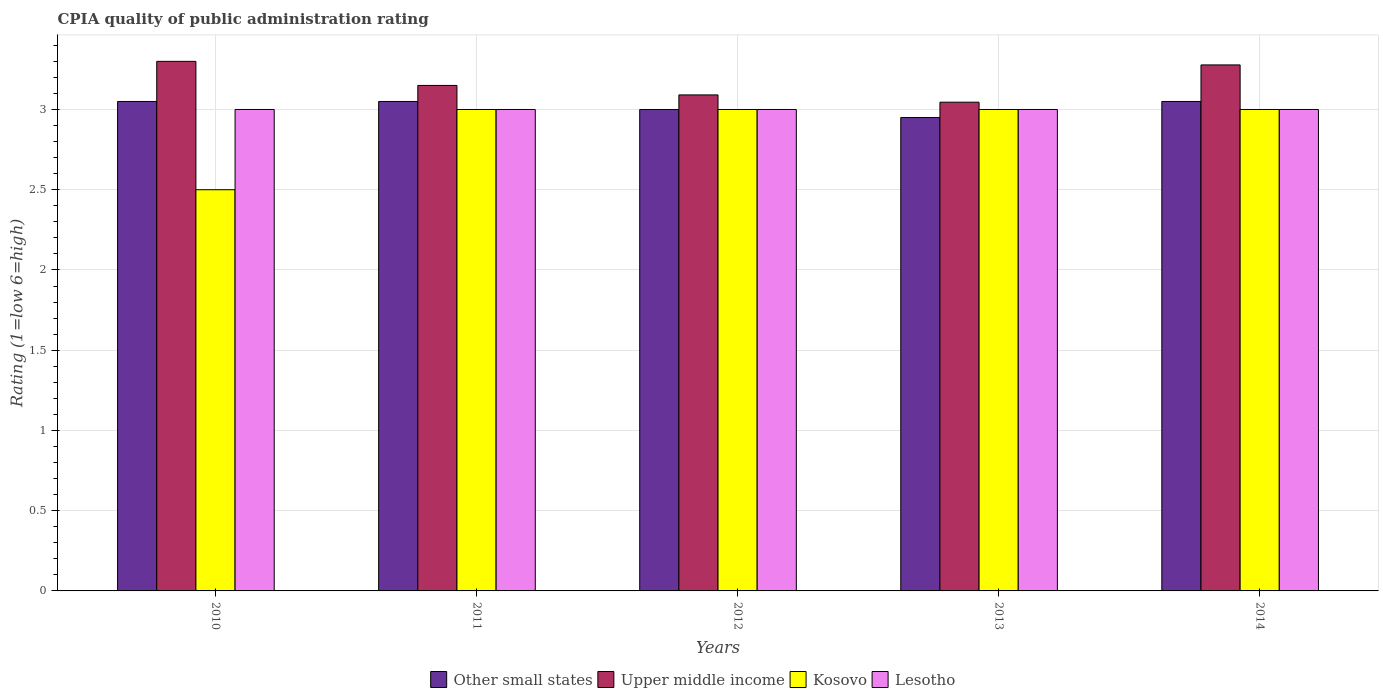How many different coloured bars are there?
Provide a short and direct response. 4. Are the number of bars per tick equal to the number of legend labels?
Your answer should be compact. Yes. Are the number of bars on each tick of the X-axis equal?
Your response must be concise. Yes. Across all years, what is the minimum CPIA rating in Upper middle income?
Ensure brevity in your answer.  3.05. In which year was the CPIA rating in Lesotho maximum?
Provide a succinct answer. 2010. In which year was the CPIA rating in Kosovo minimum?
Your response must be concise. 2010. What is the total CPIA rating in Other small states in the graph?
Your answer should be very brief. 15.1. What is the difference between the CPIA rating in Upper middle income in 2010 and the CPIA rating in Lesotho in 2014?
Your response must be concise. 0.3. What is the average CPIA rating in Lesotho per year?
Your answer should be compact. 3. In the year 2010, what is the difference between the CPIA rating in Upper middle income and CPIA rating in Kosovo?
Your answer should be compact. 0.8. What is the ratio of the CPIA rating in Other small states in 2012 to that in 2013?
Make the answer very short. 1.02. What is the difference between the highest and the second highest CPIA rating in Upper middle income?
Your response must be concise. 0.02. What is the difference between the highest and the lowest CPIA rating in Lesotho?
Your response must be concise. 0. Is it the case that in every year, the sum of the CPIA rating in Other small states and CPIA rating in Lesotho is greater than the sum of CPIA rating in Upper middle income and CPIA rating in Kosovo?
Offer a very short reply. No. What does the 3rd bar from the left in 2014 represents?
Provide a short and direct response. Kosovo. What does the 3rd bar from the right in 2012 represents?
Offer a terse response. Upper middle income. Is it the case that in every year, the sum of the CPIA rating in Kosovo and CPIA rating in Other small states is greater than the CPIA rating in Lesotho?
Offer a very short reply. Yes. What is the difference between two consecutive major ticks on the Y-axis?
Offer a very short reply. 0.5. Does the graph contain any zero values?
Offer a very short reply. No. Does the graph contain grids?
Provide a short and direct response. Yes. How are the legend labels stacked?
Offer a terse response. Horizontal. What is the title of the graph?
Your response must be concise. CPIA quality of public administration rating. What is the Rating (1=low 6=high) of Other small states in 2010?
Provide a succinct answer. 3.05. What is the Rating (1=low 6=high) in Kosovo in 2010?
Ensure brevity in your answer.  2.5. What is the Rating (1=low 6=high) of Other small states in 2011?
Keep it short and to the point. 3.05. What is the Rating (1=low 6=high) in Upper middle income in 2011?
Your answer should be compact. 3.15. What is the Rating (1=low 6=high) of Kosovo in 2011?
Keep it short and to the point. 3. What is the Rating (1=low 6=high) in Lesotho in 2011?
Offer a very short reply. 3. What is the Rating (1=low 6=high) in Upper middle income in 2012?
Provide a succinct answer. 3.09. What is the Rating (1=low 6=high) of Kosovo in 2012?
Your answer should be compact. 3. What is the Rating (1=low 6=high) of Lesotho in 2012?
Offer a very short reply. 3. What is the Rating (1=low 6=high) in Other small states in 2013?
Make the answer very short. 2.95. What is the Rating (1=low 6=high) of Upper middle income in 2013?
Keep it short and to the point. 3.05. What is the Rating (1=low 6=high) of Other small states in 2014?
Offer a terse response. 3.05. What is the Rating (1=low 6=high) in Upper middle income in 2014?
Offer a terse response. 3.28. What is the Rating (1=low 6=high) in Kosovo in 2014?
Make the answer very short. 3. What is the Rating (1=low 6=high) of Lesotho in 2014?
Your answer should be compact. 3. Across all years, what is the maximum Rating (1=low 6=high) of Other small states?
Your answer should be compact. 3.05. Across all years, what is the minimum Rating (1=low 6=high) of Other small states?
Offer a very short reply. 2.95. Across all years, what is the minimum Rating (1=low 6=high) in Upper middle income?
Your response must be concise. 3.05. Across all years, what is the minimum Rating (1=low 6=high) in Lesotho?
Keep it short and to the point. 3. What is the total Rating (1=low 6=high) of Upper middle income in the graph?
Your answer should be very brief. 15.86. What is the difference between the Rating (1=low 6=high) of Upper middle income in 2010 and that in 2011?
Provide a succinct answer. 0.15. What is the difference between the Rating (1=low 6=high) of Kosovo in 2010 and that in 2011?
Provide a short and direct response. -0.5. What is the difference between the Rating (1=low 6=high) of Lesotho in 2010 and that in 2011?
Make the answer very short. 0. What is the difference between the Rating (1=low 6=high) of Upper middle income in 2010 and that in 2012?
Offer a very short reply. 0.21. What is the difference between the Rating (1=low 6=high) in Lesotho in 2010 and that in 2012?
Provide a succinct answer. 0. What is the difference between the Rating (1=low 6=high) in Other small states in 2010 and that in 2013?
Make the answer very short. 0.1. What is the difference between the Rating (1=low 6=high) of Upper middle income in 2010 and that in 2013?
Provide a succinct answer. 0.25. What is the difference between the Rating (1=low 6=high) of Other small states in 2010 and that in 2014?
Ensure brevity in your answer.  0. What is the difference between the Rating (1=low 6=high) in Upper middle income in 2010 and that in 2014?
Give a very brief answer. 0.02. What is the difference between the Rating (1=low 6=high) of Lesotho in 2010 and that in 2014?
Give a very brief answer. 0. What is the difference between the Rating (1=low 6=high) in Upper middle income in 2011 and that in 2012?
Keep it short and to the point. 0.06. What is the difference between the Rating (1=low 6=high) of Upper middle income in 2011 and that in 2013?
Give a very brief answer. 0.1. What is the difference between the Rating (1=low 6=high) in Other small states in 2011 and that in 2014?
Your answer should be compact. 0. What is the difference between the Rating (1=low 6=high) in Upper middle income in 2011 and that in 2014?
Give a very brief answer. -0.13. What is the difference between the Rating (1=low 6=high) in Other small states in 2012 and that in 2013?
Your response must be concise. 0.05. What is the difference between the Rating (1=low 6=high) in Upper middle income in 2012 and that in 2013?
Offer a very short reply. 0.05. What is the difference between the Rating (1=low 6=high) of Kosovo in 2012 and that in 2013?
Your answer should be compact. 0. What is the difference between the Rating (1=low 6=high) in Other small states in 2012 and that in 2014?
Provide a short and direct response. -0.05. What is the difference between the Rating (1=low 6=high) in Upper middle income in 2012 and that in 2014?
Ensure brevity in your answer.  -0.19. What is the difference between the Rating (1=low 6=high) of Lesotho in 2012 and that in 2014?
Provide a short and direct response. 0. What is the difference between the Rating (1=low 6=high) in Other small states in 2013 and that in 2014?
Your answer should be very brief. -0.1. What is the difference between the Rating (1=low 6=high) in Upper middle income in 2013 and that in 2014?
Provide a succinct answer. -0.23. What is the difference between the Rating (1=low 6=high) in Kosovo in 2013 and that in 2014?
Give a very brief answer. 0. What is the difference between the Rating (1=low 6=high) of Other small states in 2010 and the Rating (1=low 6=high) of Upper middle income in 2011?
Keep it short and to the point. -0.1. What is the difference between the Rating (1=low 6=high) in Upper middle income in 2010 and the Rating (1=low 6=high) in Lesotho in 2011?
Your answer should be very brief. 0.3. What is the difference between the Rating (1=low 6=high) in Other small states in 2010 and the Rating (1=low 6=high) in Upper middle income in 2012?
Your response must be concise. -0.04. What is the difference between the Rating (1=low 6=high) of Other small states in 2010 and the Rating (1=low 6=high) of Kosovo in 2012?
Make the answer very short. 0.05. What is the difference between the Rating (1=low 6=high) of Other small states in 2010 and the Rating (1=low 6=high) of Upper middle income in 2013?
Ensure brevity in your answer.  0. What is the difference between the Rating (1=low 6=high) in Kosovo in 2010 and the Rating (1=low 6=high) in Lesotho in 2013?
Ensure brevity in your answer.  -0.5. What is the difference between the Rating (1=low 6=high) in Other small states in 2010 and the Rating (1=low 6=high) in Upper middle income in 2014?
Offer a terse response. -0.23. What is the difference between the Rating (1=low 6=high) in Other small states in 2010 and the Rating (1=low 6=high) in Kosovo in 2014?
Give a very brief answer. 0.05. What is the difference between the Rating (1=low 6=high) of Other small states in 2010 and the Rating (1=low 6=high) of Lesotho in 2014?
Provide a succinct answer. 0.05. What is the difference between the Rating (1=low 6=high) of Upper middle income in 2010 and the Rating (1=low 6=high) of Lesotho in 2014?
Your answer should be compact. 0.3. What is the difference between the Rating (1=low 6=high) in Other small states in 2011 and the Rating (1=low 6=high) in Upper middle income in 2012?
Your answer should be very brief. -0.04. What is the difference between the Rating (1=low 6=high) in Other small states in 2011 and the Rating (1=low 6=high) in Lesotho in 2012?
Your response must be concise. 0.05. What is the difference between the Rating (1=low 6=high) in Upper middle income in 2011 and the Rating (1=low 6=high) in Kosovo in 2012?
Make the answer very short. 0.15. What is the difference between the Rating (1=low 6=high) in Other small states in 2011 and the Rating (1=low 6=high) in Upper middle income in 2013?
Your answer should be compact. 0. What is the difference between the Rating (1=low 6=high) of Other small states in 2011 and the Rating (1=low 6=high) of Kosovo in 2013?
Provide a short and direct response. 0.05. What is the difference between the Rating (1=low 6=high) of Upper middle income in 2011 and the Rating (1=low 6=high) of Lesotho in 2013?
Ensure brevity in your answer.  0.15. What is the difference between the Rating (1=low 6=high) of Other small states in 2011 and the Rating (1=low 6=high) of Upper middle income in 2014?
Keep it short and to the point. -0.23. What is the difference between the Rating (1=low 6=high) in Other small states in 2011 and the Rating (1=low 6=high) in Kosovo in 2014?
Your response must be concise. 0.05. What is the difference between the Rating (1=low 6=high) of Kosovo in 2011 and the Rating (1=low 6=high) of Lesotho in 2014?
Provide a short and direct response. 0. What is the difference between the Rating (1=low 6=high) of Other small states in 2012 and the Rating (1=low 6=high) of Upper middle income in 2013?
Your response must be concise. -0.05. What is the difference between the Rating (1=low 6=high) of Other small states in 2012 and the Rating (1=low 6=high) of Kosovo in 2013?
Provide a succinct answer. 0. What is the difference between the Rating (1=low 6=high) in Upper middle income in 2012 and the Rating (1=low 6=high) in Kosovo in 2013?
Your response must be concise. 0.09. What is the difference between the Rating (1=low 6=high) in Upper middle income in 2012 and the Rating (1=low 6=high) in Lesotho in 2013?
Give a very brief answer. 0.09. What is the difference between the Rating (1=low 6=high) of Kosovo in 2012 and the Rating (1=low 6=high) of Lesotho in 2013?
Offer a very short reply. 0. What is the difference between the Rating (1=low 6=high) in Other small states in 2012 and the Rating (1=low 6=high) in Upper middle income in 2014?
Your answer should be very brief. -0.28. What is the difference between the Rating (1=low 6=high) of Other small states in 2012 and the Rating (1=low 6=high) of Kosovo in 2014?
Keep it short and to the point. 0. What is the difference between the Rating (1=low 6=high) in Other small states in 2012 and the Rating (1=low 6=high) in Lesotho in 2014?
Your answer should be very brief. 0. What is the difference between the Rating (1=low 6=high) of Upper middle income in 2012 and the Rating (1=low 6=high) of Kosovo in 2014?
Your answer should be compact. 0.09. What is the difference between the Rating (1=low 6=high) of Upper middle income in 2012 and the Rating (1=low 6=high) of Lesotho in 2014?
Your answer should be compact. 0.09. What is the difference between the Rating (1=low 6=high) in Other small states in 2013 and the Rating (1=low 6=high) in Upper middle income in 2014?
Your answer should be very brief. -0.33. What is the difference between the Rating (1=low 6=high) in Other small states in 2013 and the Rating (1=low 6=high) in Kosovo in 2014?
Provide a succinct answer. -0.05. What is the difference between the Rating (1=low 6=high) of Upper middle income in 2013 and the Rating (1=low 6=high) of Kosovo in 2014?
Ensure brevity in your answer.  0.05. What is the difference between the Rating (1=low 6=high) in Upper middle income in 2013 and the Rating (1=low 6=high) in Lesotho in 2014?
Give a very brief answer. 0.05. What is the difference between the Rating (1=low 6=high) in Kosovo in 2013 and the Rating (1=low 6=high) in Lesotho in 2014?
Provide a succinct answer. 0. What is the average Rating (1=low 6=high) in Other small states per year?
Offer a terse response. 3.02. What is the average Rating (1=low 6=high) of Upper middle income per year?
Provide a succinct answer. 3.17. What is the average Rating (1=low 6=high) in Kosovo per year?
Offer a very short reply. 2.9. What is the average Rating (1=low 6=high) of Lesotho per year?
Make the answer very short. 3. In the year 2010, what is the difference between the Rating (1=low 6=high) of Other small states and Rating (1=low 6=high) of Upper middle income?
Offer a very short reply. -0.25. In the year 2010, what is the difference between the Rating (1=low 6=high) in Other small states and Rating (1=low 6=high) in Kosovo?
Provide a succinct answer. 0.55. In the year 2010, what is the difference between the Rating (1=low 6=high) in Other small states and Rating (1=low 6=high) in Lesotho?
Provide a succinct answer. 0.05. In the year 2011, what is the difference between the Rating (1=low 6=high) of Other small states and Rating (1=low 6=high) of Upper middle income?
Offer a very short reply. -0.1. In the year 2011, what is the difference between the Rating (1=low 6=high) in Other small states and Rating (1=low 6=high) in Lesotho?
Your response must be concise. 0.05. In the year 2011, what is the difference between the Rating (1=low 6=high) in Upper middle income and Rating (1=low 6=high) in Kosovo?
Offer a very short reply. 0.15. In the year 2011, what is the difference between the Rating (1=low 6=high) of Kosovo and Rating (1=low 6=high) of Lesotho?
Ensure brevity in your answer.  0. In the year 2012, what is the difference between the Rating (1=low 6=high) in Other small states and Rating (1=low 6=high) in Upper middle income?
Make the answer very short. -0.09. In the year 2012, what is the difference between the Rating (1=low 6=high) in Upper middle income and Rating (1=low 6=high) in Kosovo?
Make the answer very short. 0.09. In the year 2012, what is the difference between the Rating (1=low 6=high) of Upper middle income and Rating (1=low 6=high) of Lesotho?
Your response must be concise. 0.09. In the year 2012, what is the difference between the Rating (1=low 6=high) of Kosovo and Rating (1=low 6=high) of Lesotho?
Ensure brevity in your answer.  0. In the year 2013, what is the difference between the Rating (1=low 6=high) in Other small states and Rating (1=low 6=high) in Upper middle income?
Ensure brevity in your answer.  -0.1. In the year 2013, what is the difference between the Rating (1=low 6=high) in Upper middle income and Rating (1=low 6=high) in Kosovo?
Ensure brevity in your answer.  0.05. In the year 2013, what is the difference between the Rating (1=low 6=high) of Upper middle income and Rating (1=low 6=high) of Lesotho?
Offer a very short reply. 0.05. In the year 2013, what is the difference between the Rating (1=low 6=high) of Kosovo and Rating (1=low 6=high) of Lesotho?
Provide a succinct answer. 0. In the year 2014, what is the difference between the Rating (1=low 6=high) of Other small states and Rating (1=low 6=high) of Upper middle income?
Provide a succinct answer. -0.23. In the year 2014, what is the difference between the Rating (1=low 6=high) of Other small states and Rating (1=low 6=high) of Lesotho?
Provide a succinct answer. 0.05. In the year 2014, what is the difference between the Rating (1=low 6=high) in Upper middle income and Rating (1=low 6=high) in Kosovo?
Give a very brief answer. 0.28. In the year 2014, what is the difference between the Rating (1=low 6=high) in Upper middle income and Rating (1=low 6=high) in Lesotho?
Keep it short and to the point. 0.28. In the year 2014, what is the difference between the Rating (1=low 6=high) in Kosovo and Rating (1=low 6=high) in Lesotho?
Offer a very short reply. 0. What is the ratio of the Rating (1=low 6=high) in Upper middle income in 2010 to that in 2011?
Your response must be concise. 1.05. What is the ratio of the Rating (1=low 6=high) of Other small states in 2010 to that in 2012?
Ensure brevity in your answer.  1.02. What is the ratio of the Rating (1=low 6=high) of Upper middle income in 2010 to that in 2012?
Your answer should be compact. 1.07. What is the ratio of the Rating (1=low 6=high) of Kosovo in 2010 to that in 2012?
Offer a very short reply. 0.83. What is the ratio of the Rating (1=low 6=high) in Lesotho in 2010 to that in 2012?
Keep it short and to the point. 1. What is the ratio of the Rating (1=low 6=high) in Other small states in 2010 to that in 2013?
Offer a very short reply. 1.03. What is the ratio of the Rating (1=low 6=high) in Upper middle income in 2010 to that in 2013?
Offer a very short reply. 1.08. What is the ratio of the Rating (1=low 6=high) of Kosovo in 2010 to that in 2013?
Make the answer very short. 0.83. What is the ratio of the Rating (1=low 6=high) of Upper middle income in 2010 to that in 2014?
Your answer should be very brief. 1.01. What is the ratio of the Rating (1=low 6=high) of Kosovo in 2010 to that in 2014?
Your response must be concise. 0.83. What is the ratio of the Rating (1=low 6=high) in Other small states in 2011 to that in 2012?
Ensure brevity in your answer.  1.02. What is the ratio of the Rating (1=low 6=high) in Upper middle income in 2011 to that in 2012?
Provide a short and direct response. 1.02. What is the ratio of the Rating (1=low 6=high) in Other small states in 2011 to that in 2013?
Make the answer very short. 1.03. What is the ratio of the Rating (1=low 6=high) in Upper middle income in 2011 to that in 2013?
Offer a very short reply. 1.03. What is the ratio of the Rating (1=low 6=high) of Kosovo in 2011 to that in 2013?
Give a very brief answer. 1. What is the ratio of the Rating (1=low 6=high) in Other small states in 2011 to that in 2014?
Your answer should be compact. 1. What is the ratio of the Rating (1=low 6=high) in Kosovo in 2011 to that in 2014?
Your answer should be compact. 1. What is the ratio of the Rating (1=low 6=high) in Other small states in 2012 to that in 2013?
Provide a short and direct response. 1.02. What is the ratio of the Rating (1=low 6=high) in Upper middle income in 2012 to that in 2013?
Your answer should be very brief. 1.01. What is the ratio of the Rating (1=low 6=high) of Other small states in 2012 to that in 2014?
Your response must be concise. 0.98. What is the ratio of the Rating (1=low 6=high) in Upper middle income in 2012 to that in 2014?
Keep it short and to the point. 0.94. What is the ratio of the Rating (1=low 6=high) in Kosovo in 2012 to that in 2014?
Your response must be concise. 1. What is the ratio of the Rating (1=low 6=high) of Other small states in 2013 to that in 2014?
Keep it short and to the point. 0.97. What is the ratio of the Rating (1=low 6=high) of Upper middle income in 2013 to that in 2014?
Your response must be concise. 0.93. What is the ratio of the Rating (1=low 6=high) in Lesotho in 2013 to that in 2014?
Make the answer very short. 1. What is the difference between the highest and the second highest Rating (1=low 6=high) of Upper middle income?
Provide a succinct answer. 0.02. What is the difference between the highest and the second highest Rating (1=low 6=high) of Kosovo?
Your answer should be compact. 0. What is the difference between the highest and the lowest Rating (1=low 6=high) of Other small states?
Your answer should be very brief. 0.1. What is the difference between the highest and the lowest Rating (1=low 6=high) of Upper middle income?
Provide a short and direct response. 0.25. What is the difference between the highest and the lowest Rating (1=low 6=high) of Lesotho?
Give a very brief answer. 0. 